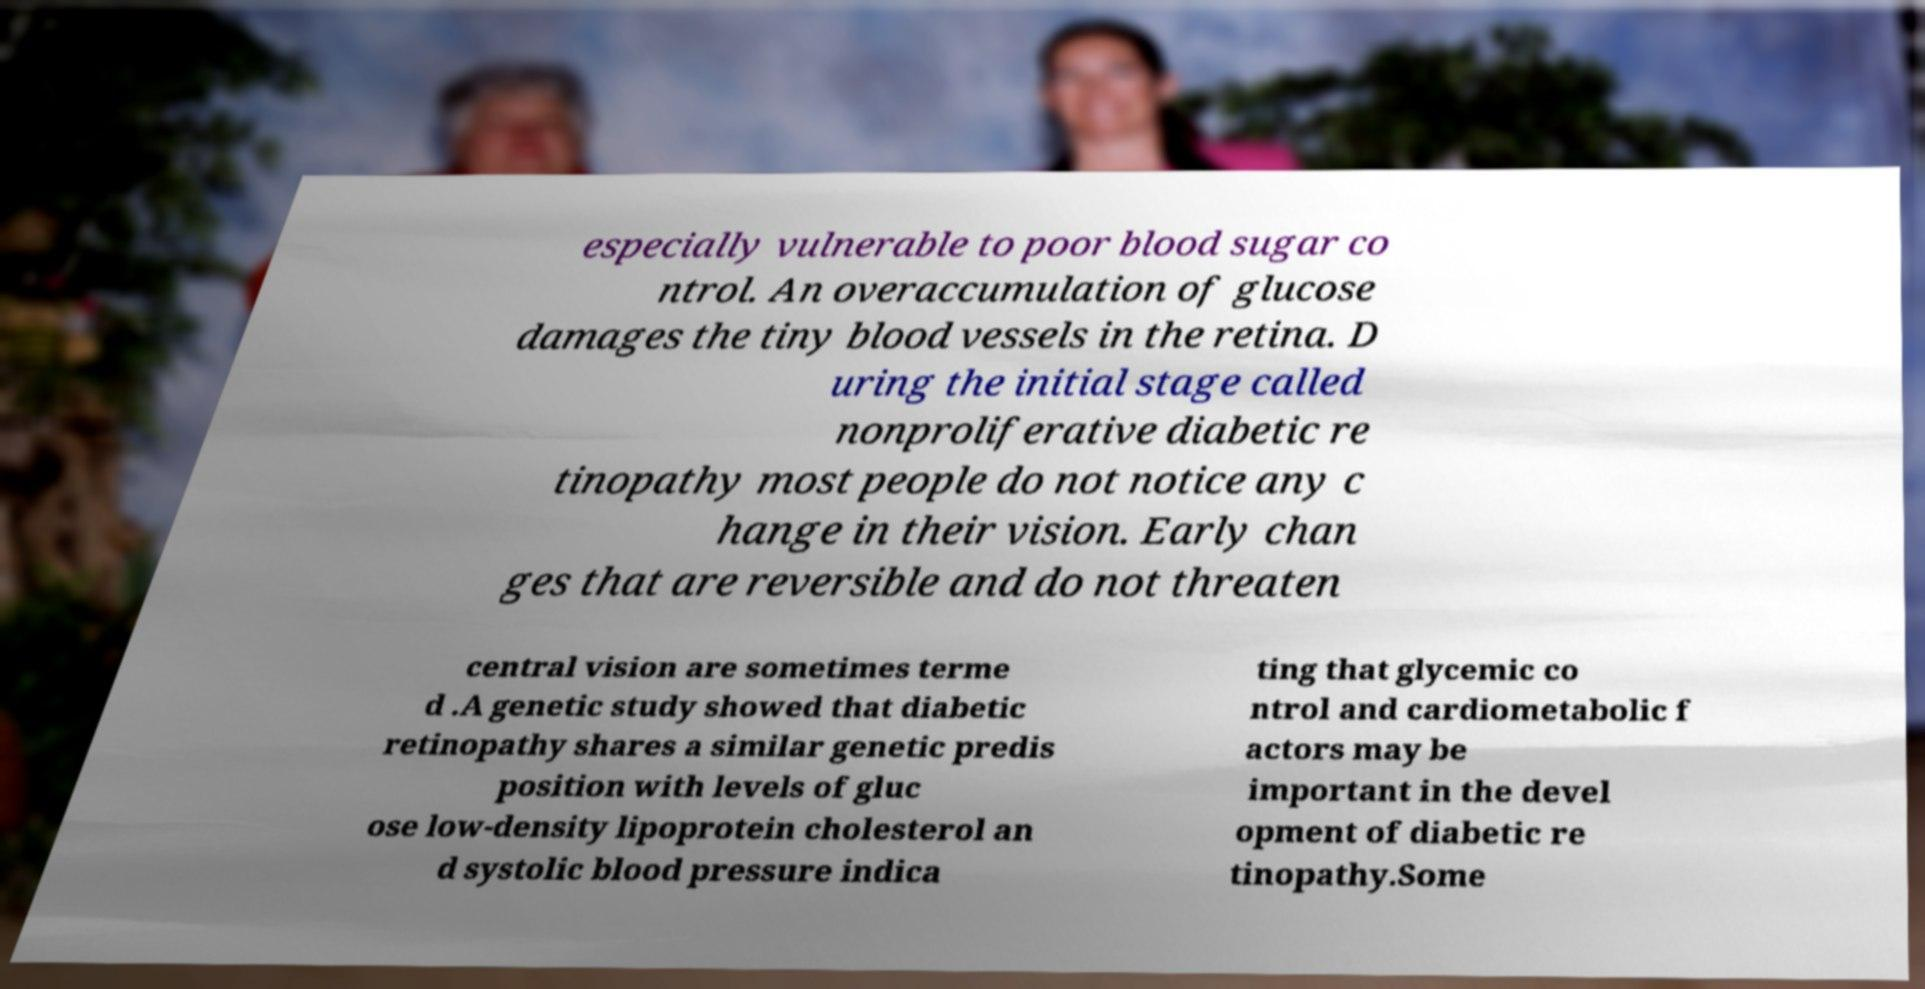Can you accurately transcribe the text from the provided image for me? especially vulnerable to poor blood sugar co ntrol. An overaccumulation of glucose damages the tiny blood vessels in the retina. D uring the initial stage called nonproliferative diabetic re tinopathy most people do not notice any c hange in their vision. Early chan ges that are reversible and do not threaten central vision are sometimes terme d .A genetic study showed that diabetic retinopathy shares a similar genetic predis position with levels of gluc ose low-density lipoprotein cholesterol an d systolic blood pressure indica ting that glycemic co ntrol and cardiometabolic f actors may be important in the devel opment of diabetic re tinopathy.Some 